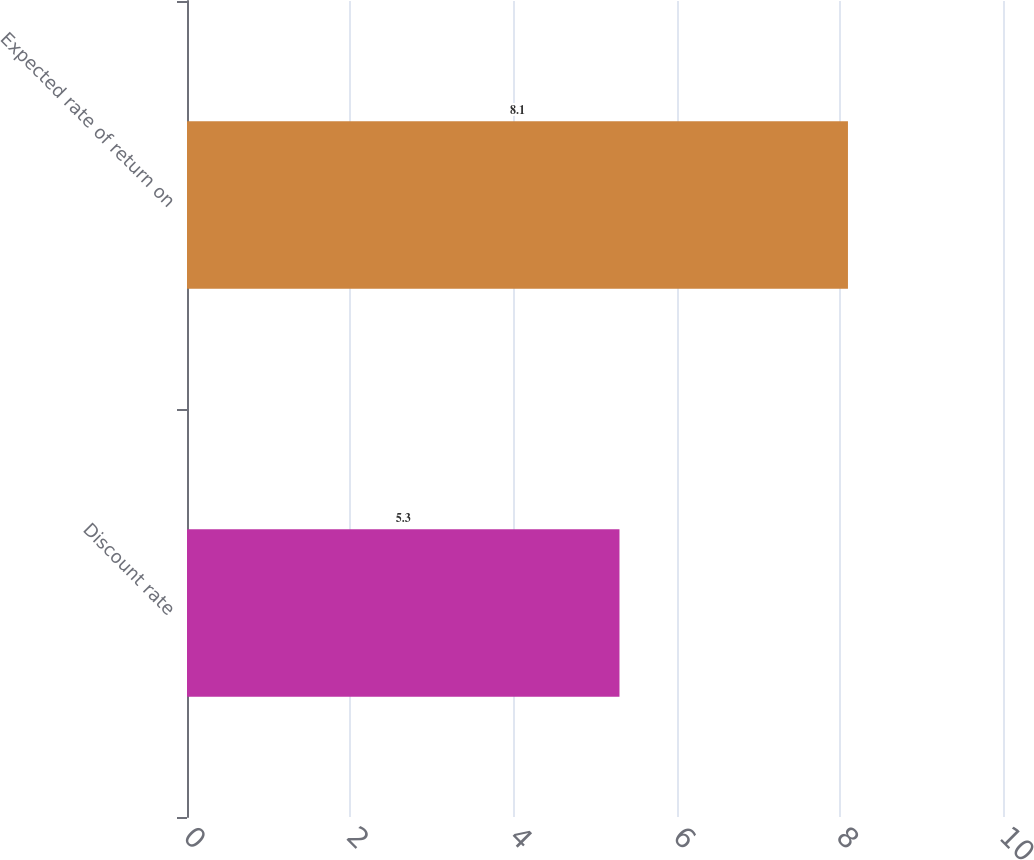<chart> <loc_0><loc_0><loc_500><loc_500><bar_chart><fcel>Discount rate<fcel>Expected rate of return on<nl><fcel>5.3<fcel>8.1<nl></chart> 